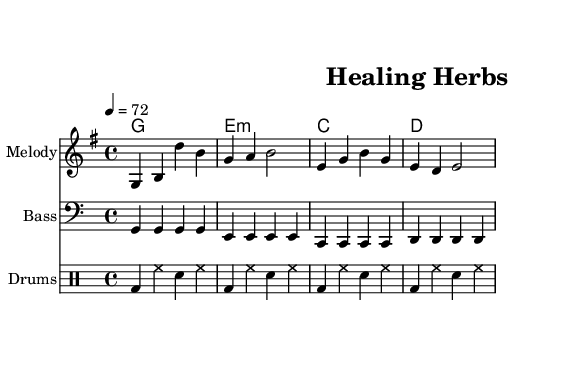What is the key signature of this music? The key signature is G major, which has one sharp (F#).
Answer: G major What is the time signature of this sheet music? The time signature is indicated as 4/4, meaning there are four beats in each measure.
Answer: 4/4 What is the tempo marking for this piece? The tempo is set at quarter note equals 72 beats per minute, which is a moderate tempo.
Answer: 72 Identify the type of chords used in the harmonies. The chords presented are standard triads commonly found in reggae music, including major and minor chords. The specific chords are G major, E minor, C major, and D major.
Answer: Major and minor How many measures are there in the melody line? The melody consists of 4 measures as indicated by the rhythmic grouping of notes.
Answer: 4 What do the lyrics suggest about the song's theme? The lyrics focus on nature and healing, indicating a connection to herbal remedies and wisdom from the earth.
Answer: Healing 